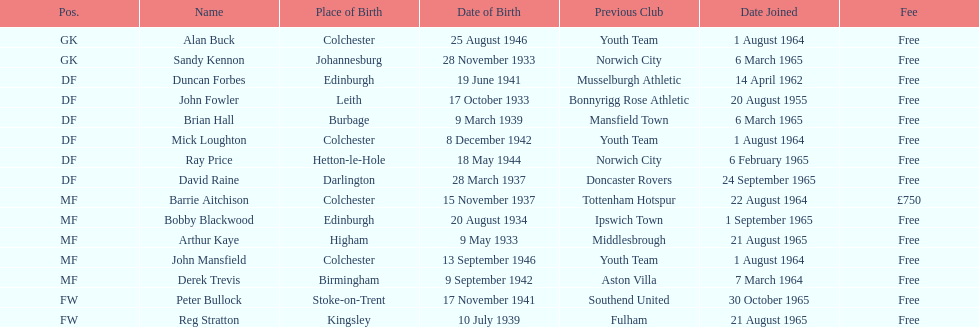What is the other fee listed, besides free? £750. 